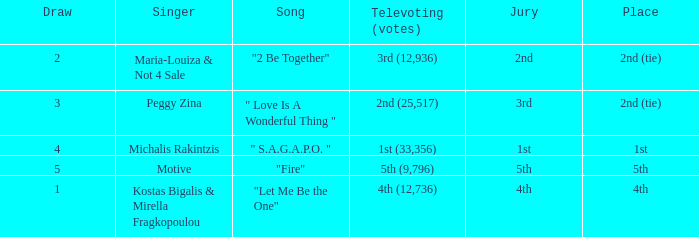Singer Maria-Louiza & Not 4 Sale had what jury? 2nd. 